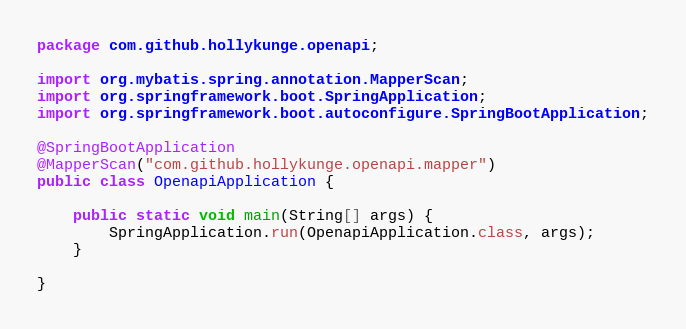Convert code to text. <code><loc_0><loc_0><loc_500><loc_500><_Java_>package com.github.hollykunge.openapi;

import org.mybatis.spring.annotation.MapperScan;
import org.springframework.boot.SpringApplication;
import org.springframework.boot.autoconfigure.SpringBootApplication;

@SpringBootApplication
@MapperScan("com.github.hollykunge.openapi.mapper")
public class OpenapiApplication {

    public static void main(String[] args) {
        SpringApplication.run(OpenapiApplication.class, args);
    }

}
</code> 